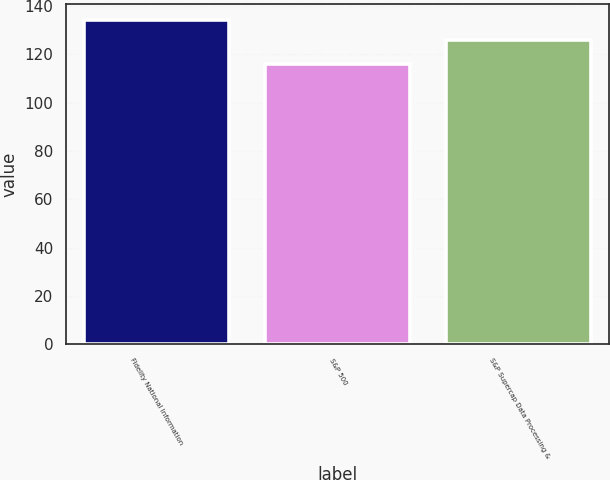Convert chart. <chart><loc_0><loc_0><loc_500><loc_500><bar_chart><fcel>Fidelity National Information<fcel>S&P 500<fcel>S&P Supercap Data Processing &<nl><fcel>134.12<fcel>116<fcel>126.06<nl></chart> 